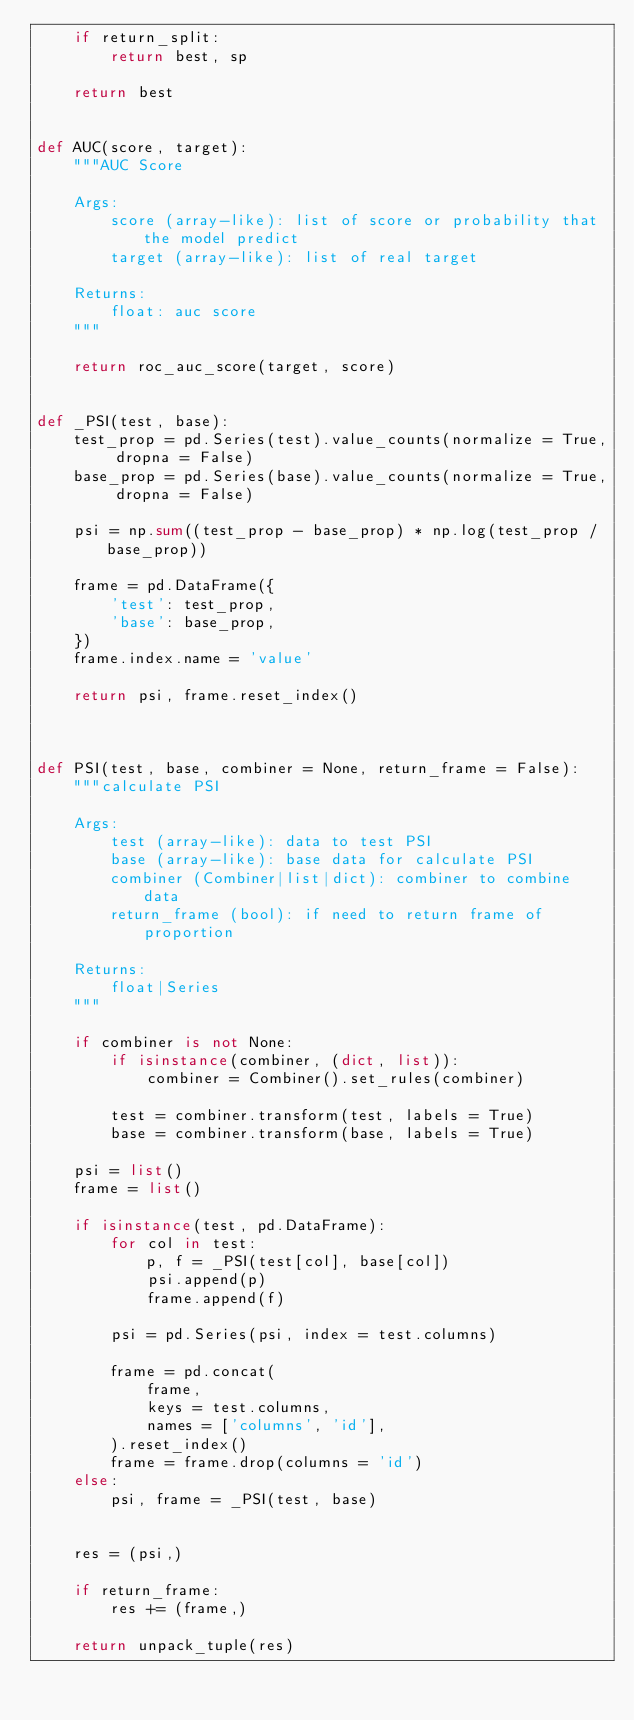Convert code to text. <code><loc_0><loc_0><loc_500><loc_500><_Python_>    if return_split:
        return best, sp

    return best


def AUC(score, target):
    """AUC Score

    Args:
        score (array-like): list of score or probability that the model predict
        target (array-like): list of real target

    Returns:
        float: auc score
    """

    return roc_auc_score(target, score)


def _PSI(test, base):
    test_prop = pd.Series(test).value_counts(normalize = True, dropna = False)
    base_prop = pd.Series(base).value_counts(normalize = True, dropna = False)

    psi = np.sum((test_prop - base_prop) * np.log(test_prop / base_prop))

    frame = pd.DataFrame({
        'test': test_prop,
        'base': base_prop,
    })
    frame.index.name = 'value'

    return psi, frame.reset_index()



def PSI(test, base, combiner = None, return_frame = False):
    """calculate PSI

    Args:
        test (array-like): data to test PSI
        base (array-like): base data for calculate PSI
        combiner (Combiner|list|dict): combiner to combine data
        return_frame (bool): if need to return frame of proportion

    Returns:
        float|Series
    """

    if combiner is not None:
        if isinstance(combiner, (dict, list)):
            combiner = Combiner().set_rules(combiner)

        test = combiner.transform(test, labels = True)
        base = combiner.transform(base, labels = True)

    psi = list()
    frame = list()

    if isinstance(test, pd.DataFrame):
        for col in test:
            p, f = _PSI(test[col], base[col])
            psi.append(p)
            frame.append(f)

        psi = pd.Series(psi, index = test.columns)

        frame = pd.concat(
            frame,
            keys = test.columns,
            names = ['columns', 'id'],
        ).reset_index()
        frame = frame.drop(columns = 'id')
    else:
        psi, frame = _PSI(test, base)


    res = (psi,)

    if return_frame:
        res += (frame,)

    return unpack_tuple(res)
</code> 